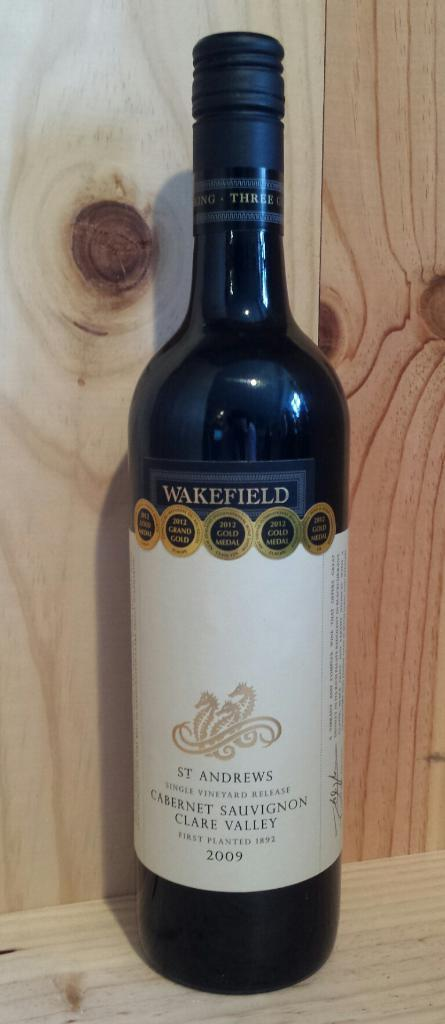Provide a one-sentence caption for the provided image. The wine is from St. Andrews and has Wakefield at the top of the label. 